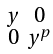Convert formula to latex. <formula><loc_0><loc_0><loc_500><loc_500>\begin{smallmatrix} y & 0 \\ 0 & y ^ { p } \end{smallmatrix}</formula> 